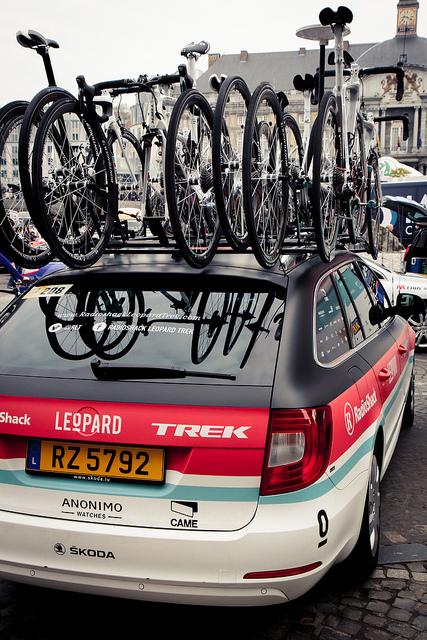What type of car is it?
Quick response, please. Skoda. What is the no on plate of the car?
Concise answer only. Rz5792. How many times has each one of the bikes been rode?
Short answer required. 5. 